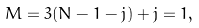<formula> <loc_0><loc_0><loc_500><loc_500>M = 3 ( N - 1 - j ) + j = 1 ,</formula> 